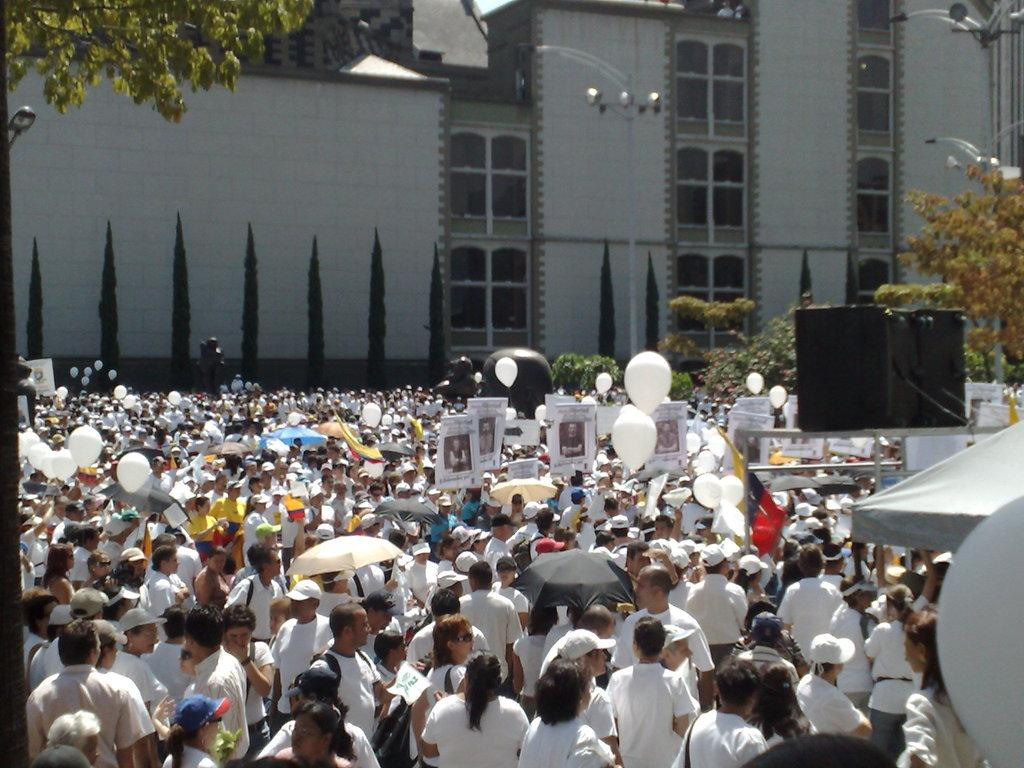How many people are in the group visible in the image? There is a group of people in the image, but the exact number is not specified. What are some people using to protect themselves from the elements? Some people are holding umbrellas in the image. What decorative items can be seen in the image? There are balloons, plants, trees, poles, banners, and boxes in the image. What type of structure is visible in the background of the image? There is a building in the background of the image. Can you see any smoke coming from the building in the image? There is no smoke visible in the image, as the focus is on the group of people and the various objects surrounding them. 